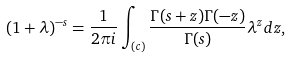Convert formula to latex. <formula><loc_0><loc_0><loc_500><loc_500>( 1 + \lambda ) ^ { - s } = \frac { 1 } { 2 \pi i } \int _ { ( c ) } \frac { \Gamma ( s + z ) \Gamma ( - z ) } { \Gamma ( s ) } \lambda ^ { z } d z ,</formula> 